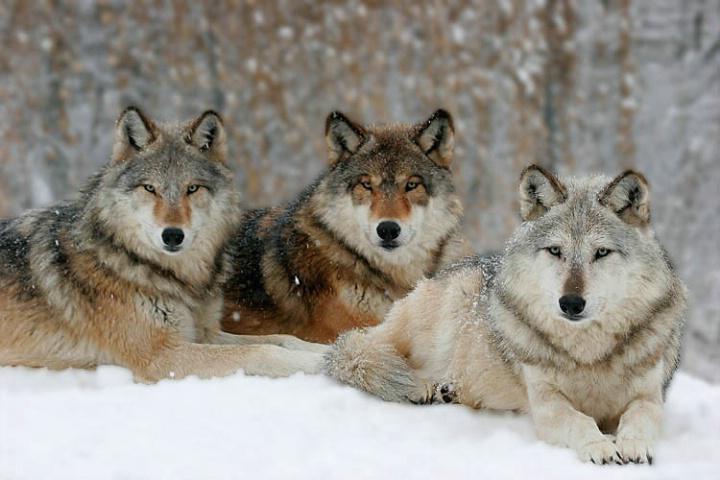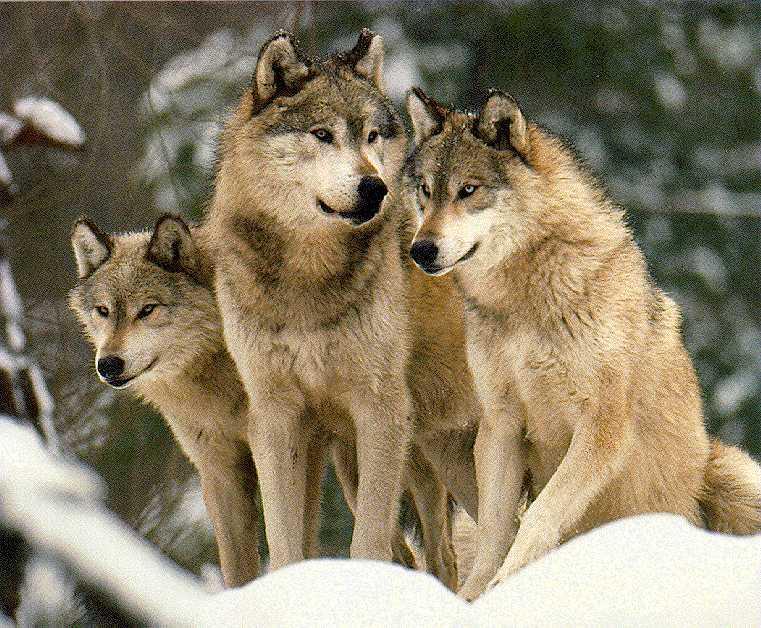The first image is the image on the left, the second image is the image on the right. For the images shown, is this caption "One image has three wolves without any snow." true? Answer yes or no. No. 